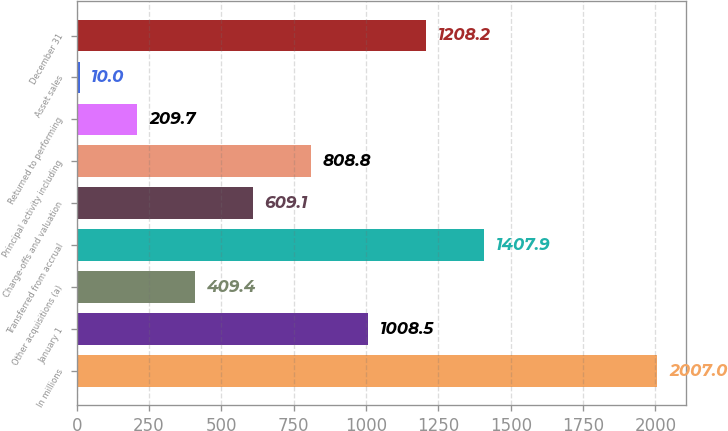Convert chart to OTSL. <chart><loc_0><loc_0><loc_500><loc_500><bar_chart><fcel>In millions<fcel>January 1<fcel>Other acquisitions (a)<fcel>Transferred from accrual<fcel>Charge-offs and valuation<fcel>Principal activity including<fcel>Returned to performing<fcel>Asset sales<fcel>December 31<nl><fcel>2007<fcel>1008.5<fcel>409.4<fcel>1407.9<fcel>609.1<fcel>808.8<fcel>209.7<fcel>10<fcel>1208.2<nl></chart> 